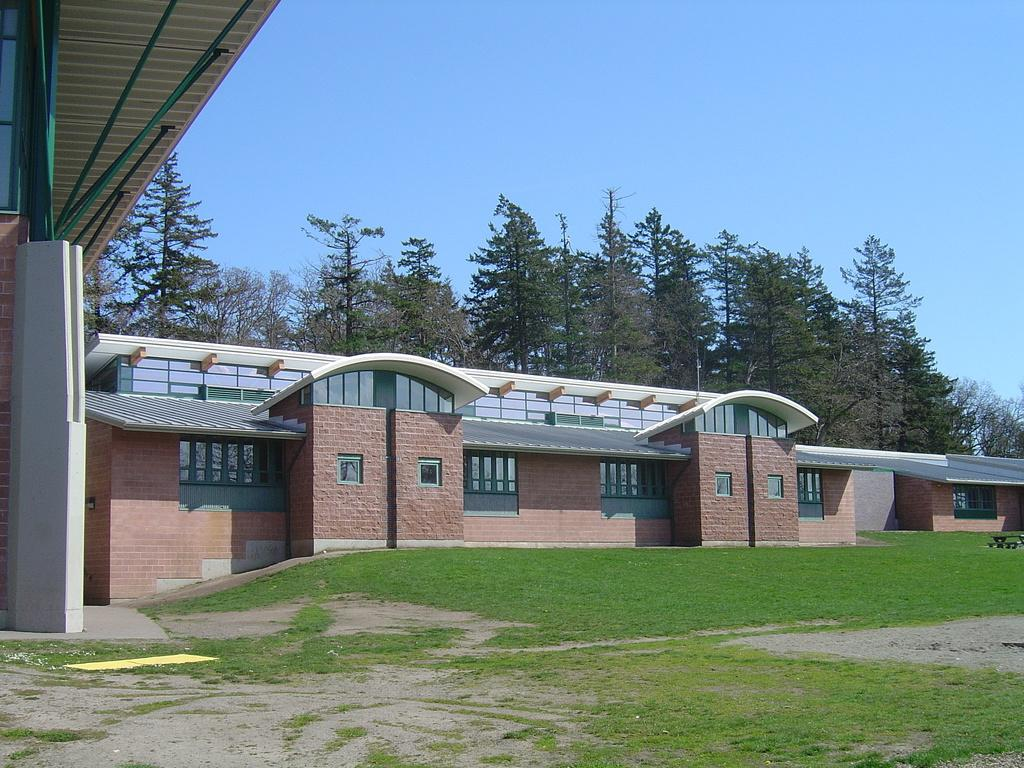What is the main structure in the image? There is a building in the center of the image. What type of ground is visible at the bottom of the image? There is grass at the bottom of the image. What can be seen in the background of the image? There are trees and the sky visible in the background of the image. What room is being used for the process in the image? There is no room or process depicted in the image; it only shows a building, grass, trees, and the sky. 